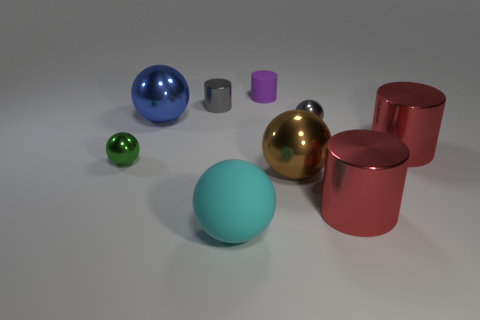Subtract all red cylinders. How many were subtracted if there are1red cylinders left? 1 Subtract all rubber balls. How many balls are left? 4 Subtract all green balls. How many red cylinders are left? 2 Subtract all gray cylinders. How many cylinders are left? 3 Subtract all gray balls. Subtract all brown cubes. How many balls are left? 4 Subtract all cylinders. How many objects are left? 5 Subtract all small cyan matte spheres. Subtract all blue shiny things. How many objects are left? 8 Add 1 rubber balls. How many rubber balls are left? 2 Add 1 red shiny cylinders. How many red shiny cylinders exist? 3 Subtract 0 cyan cubes. How many objects are left? 9 